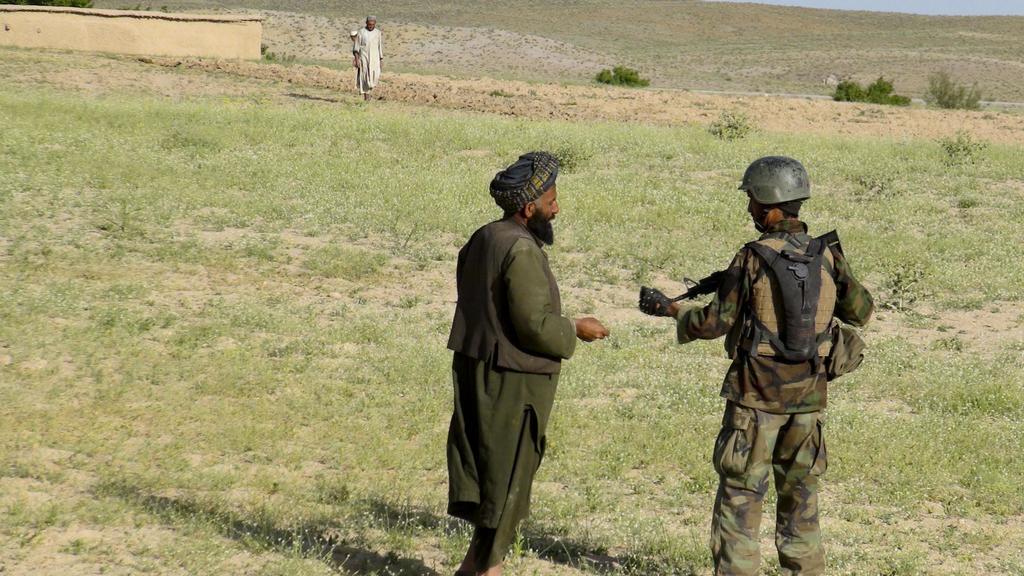Describe this image in one or two sentences. In this image there are two persons standing on the surface of the grass, one of them is holding a gun in his hand. In the background there is a person standing and a wall. 